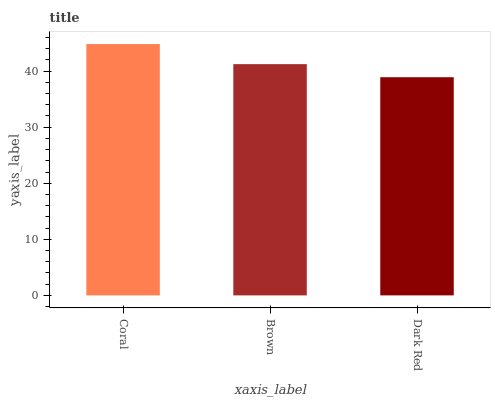Is Brown the minimum?
Answer yes or no. No. Is Brown the maximum?
Answer yes or no. No. Is Coral greater than Brown?
Answer yes or no. Yes. Is Brown less than Coral?
Answer yes or no. Yes. Is Brown greater than Coral?
Answer yes or no. No. Is Coral less than Brown?
Answer yes or no. No. Is Brown the high median?
Answer yes or no. Yes. Is Brown the low median?
Answer yes or no. Yes. Is Dark Red the high median?
Answer yes or no. No. Is Coral the low median?
Answer yes or no. No. 